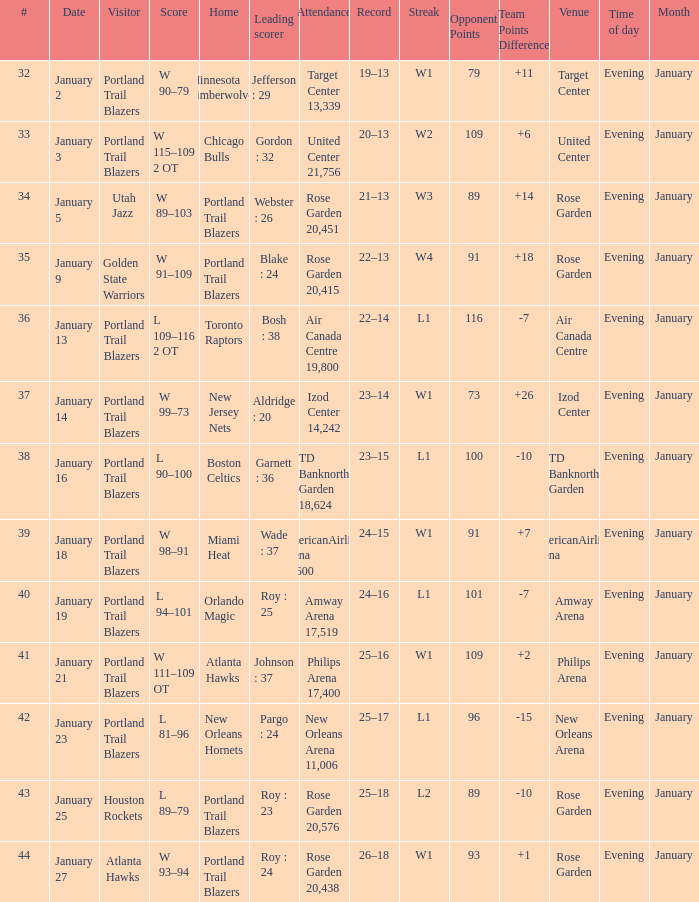Would you mind parsing the complete table? {'header': ['#', 'Date', 'Visitor', 'Score', 'Home', 'Leading scorer', 'Attendance', 'Record', 'Streak', 'Opponent Points', 'Team Points Difference', 'Venue', 'Time of day', 'Month'], 'rows': [['32', 'January 2', 'Portland Trail Blazers', 'W 90–79', 'Minnesota Timberwolves', 'Jefferson : 29', 'Target Center 13,339', '19–13', 'W1', '79', '+11', 'Target Center', 'Evening', 'January'], ['33', 'January 3', 'Portland Trail Blazers', 'W 115–109 2 OT', 'Chicago Bulls', 'Gordon : 32', 'United Center 21,756', '20–13', 'W2', '109', '+6', 'United Center', 'Evening', 'January'], ['34', 'January 5', 'Utah Jazz', 'W 89–103', 'Portland Trail Blazers', 'Webster : 26', 'Rose Garden 20,451', '21–13', 'W3', '89', '+14', 'Rose Garden', 'Evening', 'January'], ['35', 'January 9', 'Golden State Warriors', 'W 91–109', 'Portland Trail Blazers', 'Blake : 24', 'Rose Garden 20,415', '22–13', 'W4', '91', '+18', 'Rose Garden', 'Evening', 'January'], ['36', 'January 13', 'Portland Trail Blazers', 'L 109–116 2 OT', 'Toronto Raptors', 'Bosh : 38', 'Air Canada Centre 19,800', '22–14', 'L1', '116', '-7', 'Air Canada Centre', 'Evening', 'January'], ['37', 'January 14', 'Portland Trail Blazers', 'W 99–73', 'New Jersey Nets', 'Aldridge : 20', 'Izod Center 14,242', '23–14', 'W1', '73', '+26', 'Izod Center', 'Evening', 'January'], ['38', 'January 16', 'Portland Trail Blazers', 'L 90–100', 'Boston Celtics', 'Garnett : 36', 'TD Banknorth Garden 18,624', '23–15', 'L1', '100', '-10', 'TD Banknorth Garden', 'Evening', 'January'], ['39', 'January 18', 'Portland Trail Blazers', 'W 98–91', 'Miami Heat', 'Wade : 37', 'AmericanAirlines Arena 19,600', '24–15', 'W1', '91', '+7', 'AmericanAirlines Arena', 'Evening', 'January'], ['40', 'January 19', 'Portland Trail Blazers', 'L 94–101', 'Orlando Magic', 'Roy : 25', 'Amway Arena 17,519', '24–16', 'L1', '101', '-7', 'Amway Arena', 'Evening', 'January'], ['41', 'January 21', 'Portland Trail Blazers', 'W 111–109 OT', 'Atlanta Hawks', 'Johnson : 37', 'Philips Arena 17,400', '25–16', 'W1', '109', '+2', 'Philips Arena', 'Evening', 'January'], ['42', 'January 23', 'Portland Trail Blazers', 'L 81–96', 'New Orleans Hornets', 'Pargo : 24', 'New Orleans Arena 11,006', '25–17', 'L1', '96', '-15', 'New Orleans Arena', 'Evening', 'January'], ['43', 'January 25', 'Houston Rockets', 'L 89–79', 'Portland Trail Blazers', 'Roy : 23', 'Rose Garden 20,576', '25–18', 'L2', '89', '-10', 'Rose Garden', 'Evening', 'January'], ['44', 'January 27', 'Atlanta Hawks', 'W 93–94', 'Portland Trail Blazers', 'Roy : 24', 'Rose Garden 20,438', '26–18', 'W1', '93', '+1', 'Rose Garden', 'Evening', 'January']]} What are all the records with a score is w 98–91 24–15. 